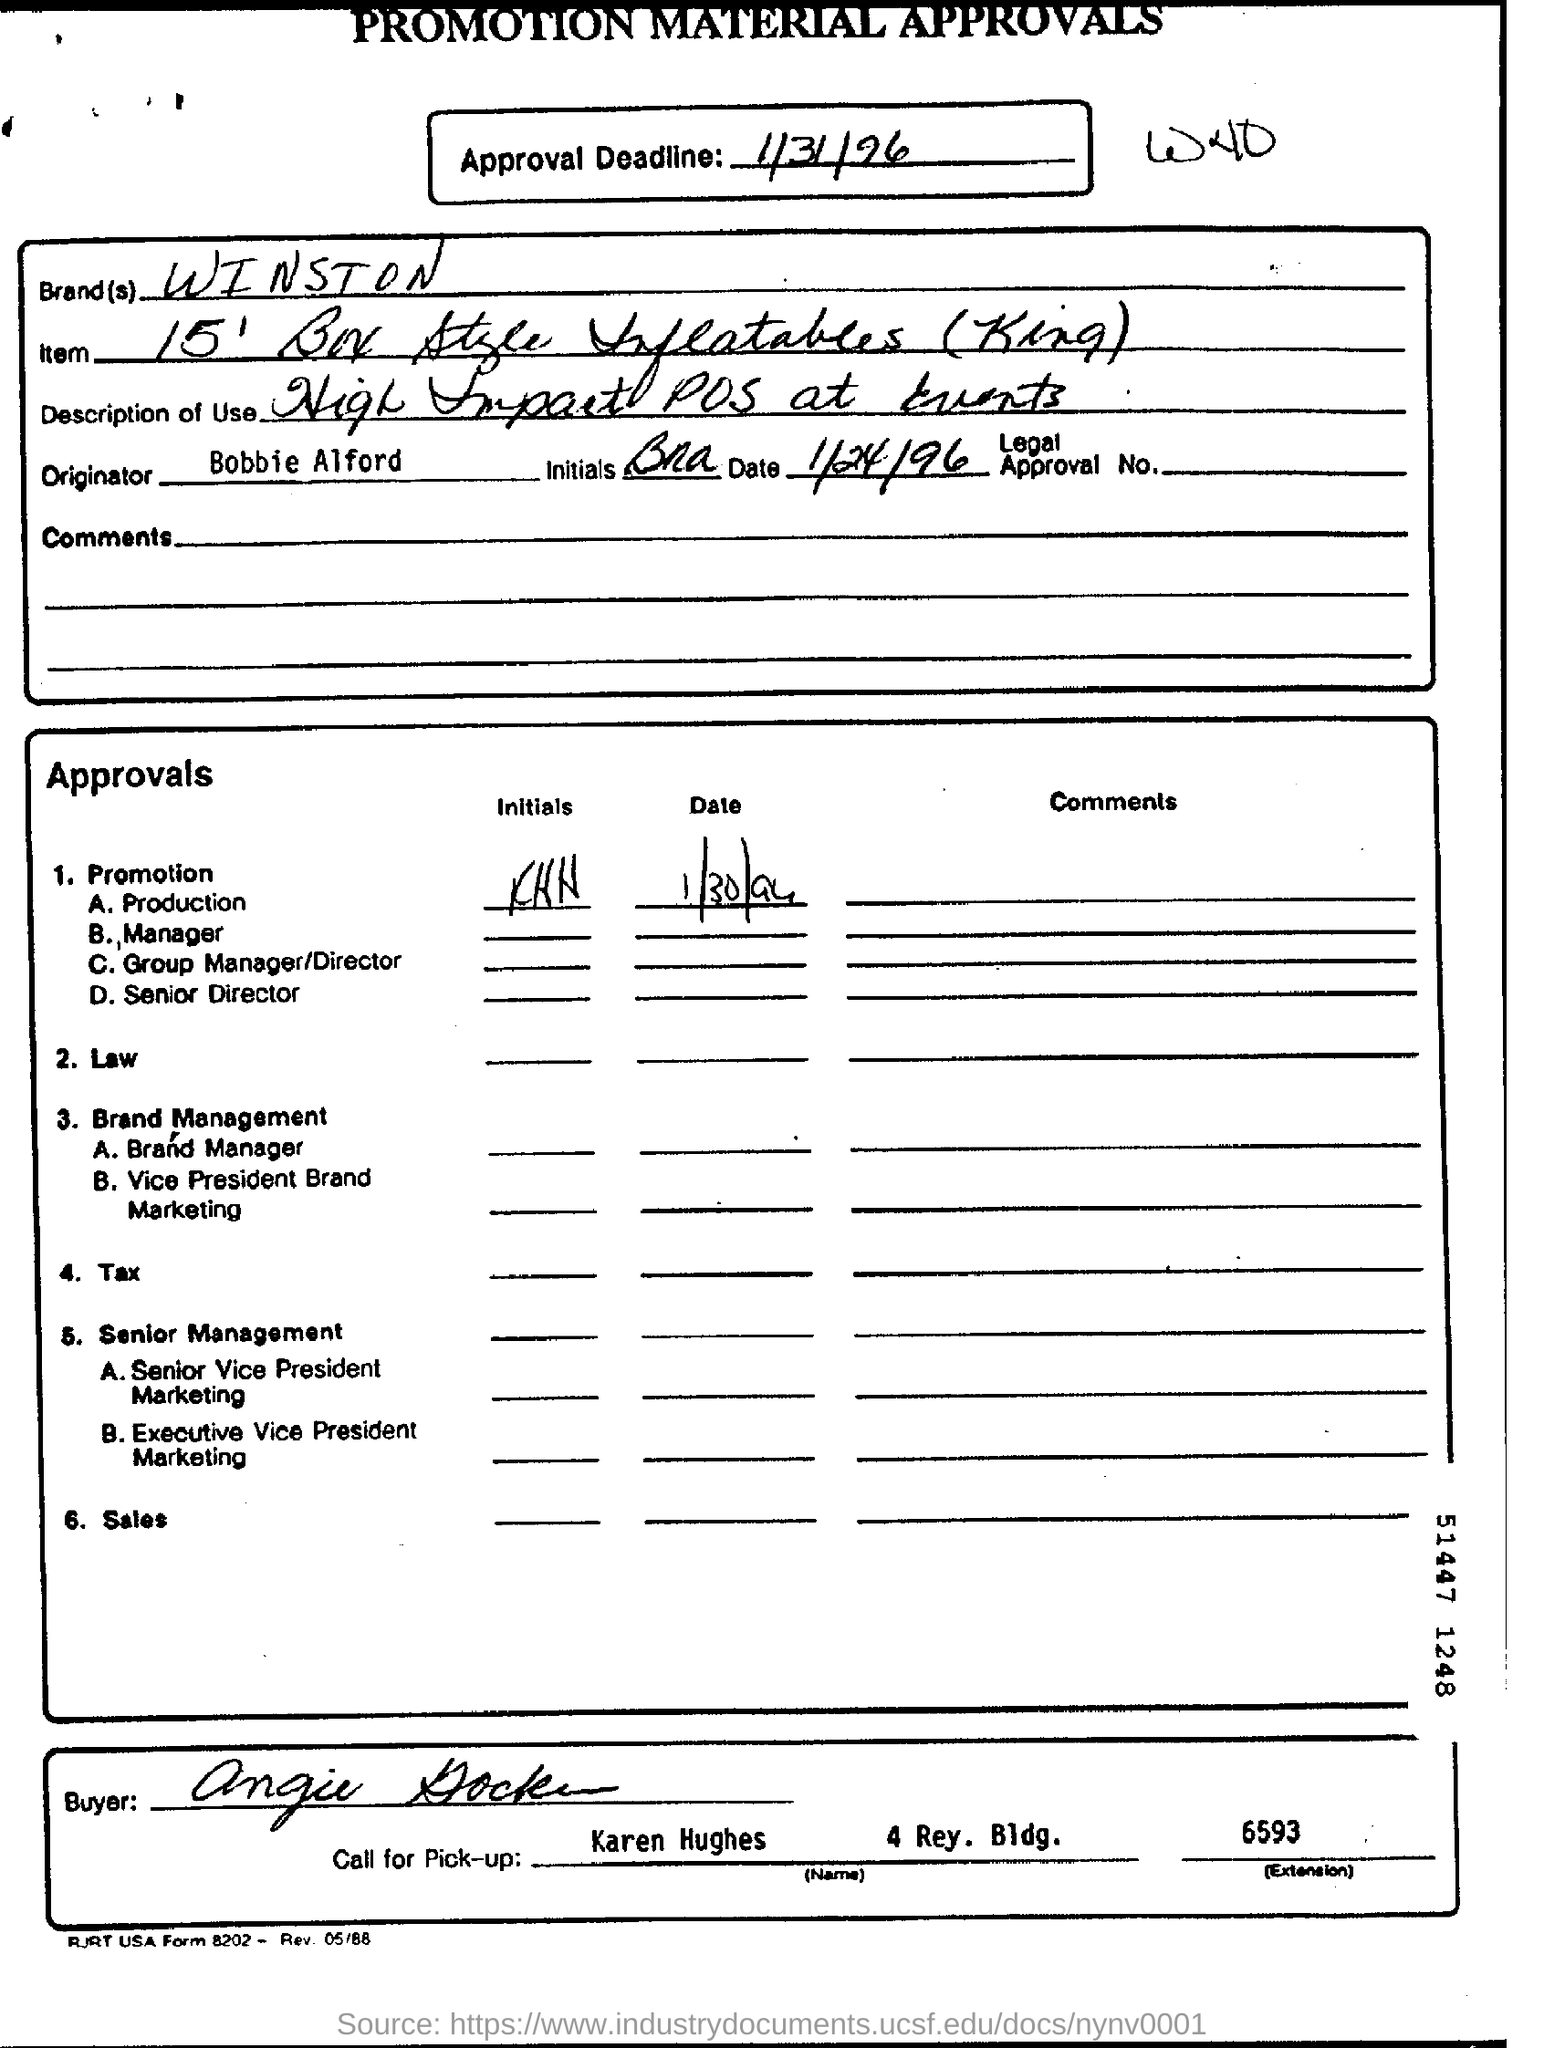Outline some significant characteristics in this image. The term 'Call for Pick-up' refers to a specific request or instruction known as 'Name' and attributed to Karen Hughes. The approval deadline is 1/31/96. The brand in question is Winston. 